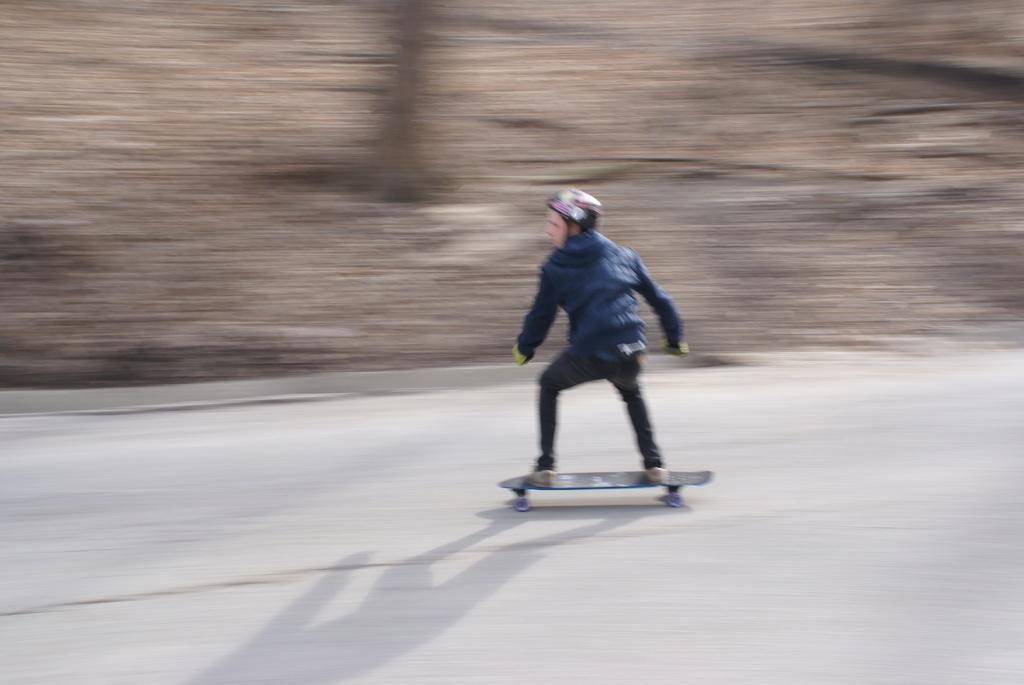Who is present in the image? There is a person in the image. What is the person wearing on their head? The person is wearing a helmet. What is the person standing on in the image? The person is standing on a skateboard. What is the person doing in the image? The person is skating on the road. Can you describe the background of the image? The background of the image is blurred. How many eggs can be seen in the image? There are no eggs present in the image. What type of writing can be seen on the person's helmet? There is no writing visible on the person's helmet in the image. 